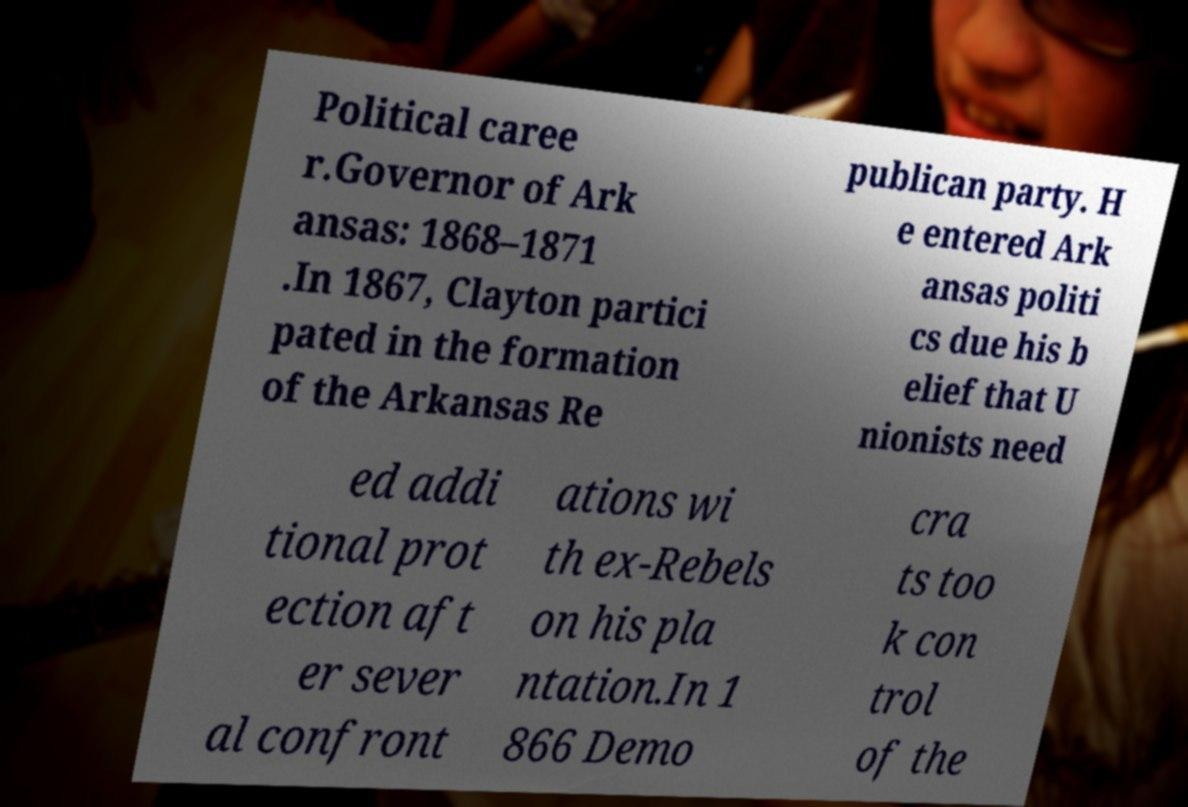There's text embedded in this image that I need extracted. Can you transcribe it verbatim? Political caree r.Governor of Ark ansas: 1868–1871 .In 1867, Clayton partici pated in the formation of the Arkansas Re publican party. H e entered Ark ansas politi cs due his b elief that U nionists need ed addi tional prot ection aft er sever al confront ations wi th ex-Rebels on his pla ntation.In 1 866 Demo cra ts too k con trol of the 